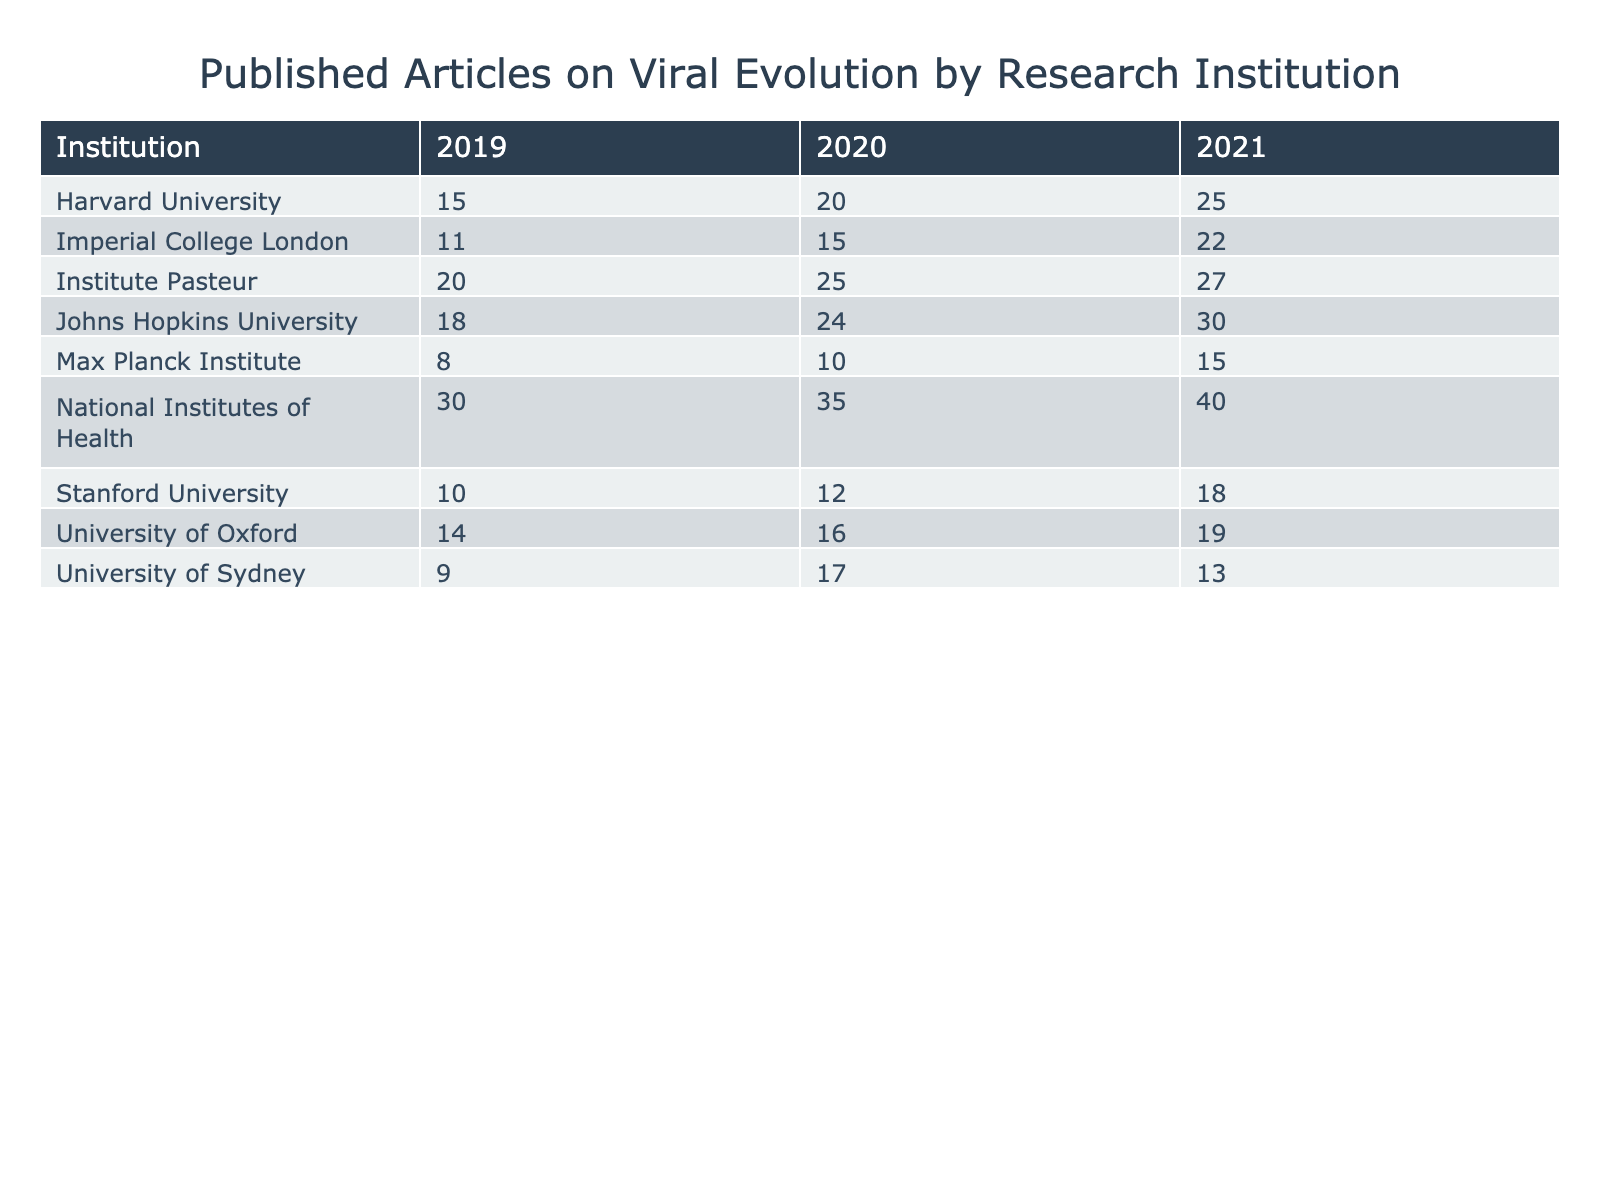What institution published the highest number of articles in 2021? Looking at the 2021 column, Johns Hopkins University has the highest value with 30 published articles.
Answer: Johns Hopkins University How many articles did the National Institutes of Health publish in total from 2019 to 2021? Adding the articles published each year, we get 30 (2019) + 35 (2020) + 40 (2021) = 105.
Answer: 105 Did Stanford University publish more articles in 2020 than in 2019? In 2020, Stanford University published 12 articles, compared to 10 in 2019, thus it published more in 2020.
Answer: Yes Which institution had the least number of published articles in 2019? In 2019, the Max Planck Institute published the least with 8 articles compared to the other institutions.
Answer: Max Planck Institute What is the average number of articles published by Harvard University from 2019 to 2021? The total number of articles published is 15 (2019) + 20 (2020) + 25 (2021) = 60. Since there are 3 years, the average is 60 / 3 = 20.
Answer: 20 Which year saw the highest total number of articles published across all institutions? Summing the published articles for each year: 2019 = 15 + 10 + 18 + 14 + 11 + 9 + 20 + 30 + 8 = 135; 2020 = 20 + 12 + 24 + 16 + 15 + 17 + 25 + 35 + 10 = 144; 2021 = 25 + 18 + 30 + 19 + 22 + 13 + 27 + 40 + 15 = 239. 2021 has the highest total of 239.
Answer: 2021 How many more articles did the University of Oxford publish in 2021 compared to 2019? In 2021, the University of Oxford published 19 articles, and in 2019 it published 14. The difference is 19 - 14 = 5.
Answer: 5 What is the total number of published articles for the Institute Pasteur for the years 2019 to 2021? Adding the articles from 2019 (20), 2020 (25), and 2021 (27) gives a total of 20 + 25 + 27 = 72.
Answer: 72 Which institution consistently increased its published articles from 2019 to 2021? Upon reviewing the values, Johns Hopkins University consistently increased its published articles: 18 in 2019, 24 in 2020, and 30 in 2021.
Answer: Johns Hopkins University Which two institutions had the same number of published articles in 2020? Looking at the data, University of Oxford and Imperial College London both published 15 articles in 2020.
Answer: University of Oxford and Imperial College London 